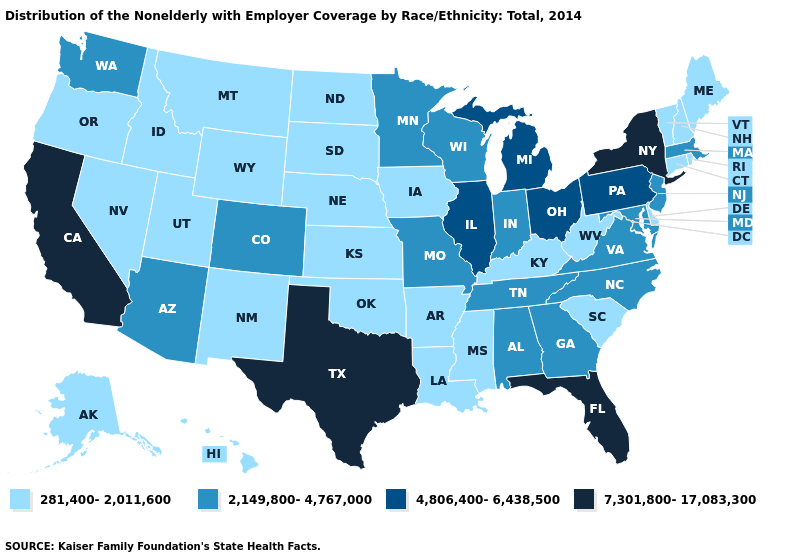What is the highest value in the USA?
Short answer required. 7,301,800-17,083,300. Does the first symbol in the legend represent the smallest category?
Concise answer only. Yes. Does the map have missing data?
Give a very brief answer. No. Among the states that border Texas , which have the lowest value?
Short answer required. Arkansas, Louisiana, New Mexico, Oklahoma. Which states have the lowest value in the USA?
Quick response, please. Alaska, Arkansas, Connecticut, Delaware, Hawaii, Idaho, Iowa, Kansas, Kentucky, Louisiana, Maine, Mississippi, Montana, Nebraska, Nevada, New Hampshire, New Mexico, North Dakota, Oklahoma, Oregon, Rhode Island, South Carolina, South Dakota, Utah, Vermont, West Virginia, Wyoming. Name the states that have a value in the range 4,806,400-6,438,500?
Be succinct. Illinois, Michigan, Ohio, Pennsylvania. Does Minnesota have a lower value than Mississippi?
Short answer required. No. Name the states that have a value in the range 2,149,800-4,767,000?
Give a very brief answer. Alabama, Arizona, Colorado, Georgia, Indiana, Maryland, Massachusetts, Minnesota, Missouri, New Jersey, North Carolina, Tennessee, Virginia, Washington, Wisconsin. What is the value of Michigan?
Be succinct. 4,806,400-6,438,500. Among the states that border Texas , which have the lowest value?
Short answer required. Arkansas, Louisiana, New Mexico, Oklahoma. What is the value of Alabama?
Write a very short answer. 2,149,800-4,767,000. Does Oregon have a higher value than Nevada?
Quick response, please. No. Which states have the highest value in the USA?
Write a very short answer. California, Florida, New York, Texas. What is the value of Pennsylvania?
Keep it brief. 4,806,400-6,438,500. Does Pennsylvania have a higher value than Alabama?
Answer briefly. Yes. 